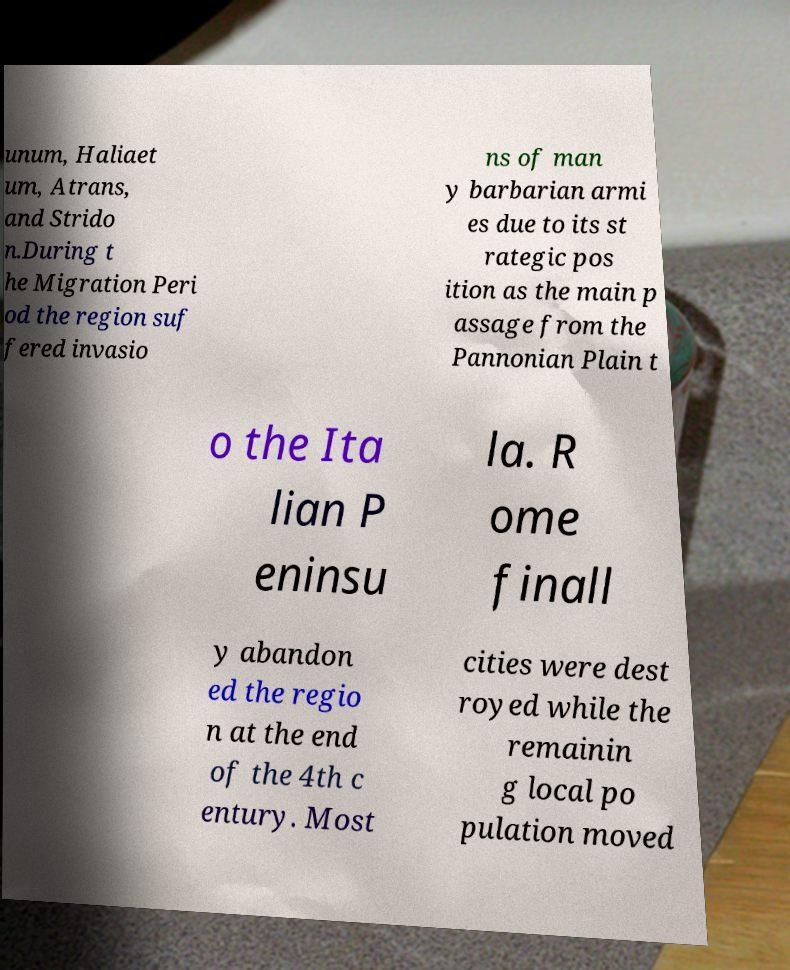Could you assist in decoding the text presented in this image and type it out clearly? unum, Haliaet um, Atrans, and Strido n.During t he Migration Peri od the region suf fered invasio ns of man y barbarian armi es due to its st rategic pos ition as the main p assage from the Pannonian Plain t o the Ita lian P eninsu la. R ome finall y abandon ed the regio n at the end of the 4th c entury. Most cities were dest royed while the remainin g local po pulation moved 